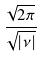Convert formula to latex. <formula><loc_0><loc_0><loc_500><loc_500>\frac { \sqrt { 2 \pi } } { \sqrt { | \nu | } }</formula> 